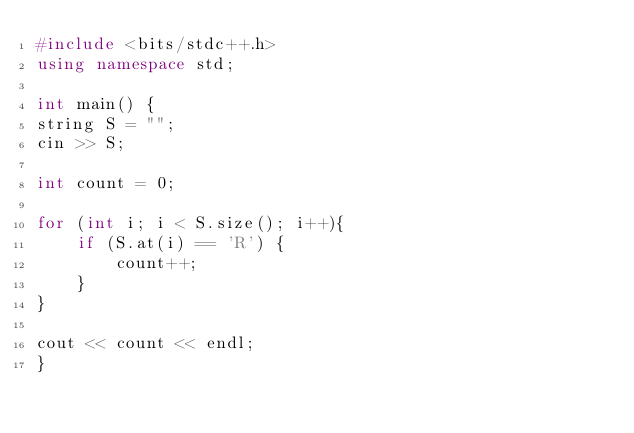<code> <loc_0><loc_0><loc_500><loc_500><_C++_>#include <bits/stdc++.h>
using namespace std;
 
int main() {
string S = "";
cin >> S;

int count = 0;

for (int i; i < S.size(); i++){
    if (S.at(i) == 'R') {
        count++;
    }
}

cout << count << endl;
}</code> 